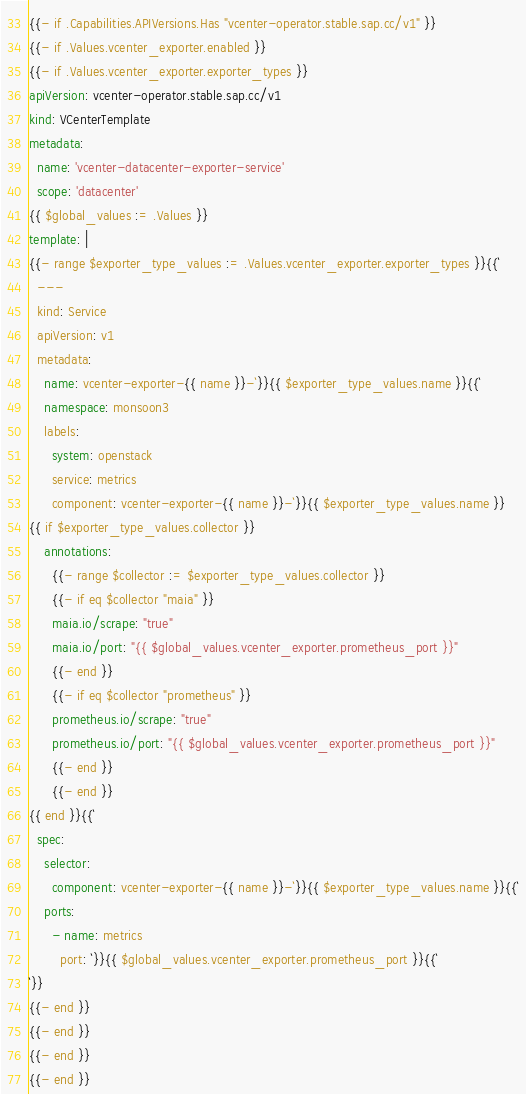Convert code to text. <code><loc_0><loc_0><loc_500><loc_500><_YAML_>{{- if .Capabilities.APIVersions.Has "vcenter-operator.stable.sap.cc/v1" }}
{{- if .Values.vcenter_exporter.enabled }}
{{- if .Values.vcenter_exporter.exporter_types }}
apiVersion: vcenter-operator.stable.sap.cc/v1
kind: VCenterTemplate
metadata:
  name: 'vcenter-datacenter-exporter-service'
  scope: 'datacenter'
{{ $global_values := .Values }}
template: |
{{- range $exporter_type_values := .Values.vcenter_exporter.exporter_types }}{{`
  ---
  kind: Service
  apiVersion: v1
  metadata:
    name: vcenter-exporter-{{ name }}-`}}{{ $exporter_type_values.name }}{{`
    namespace: monsoon3
    labels:
      system: openstack
      service: metrics
      component: vcenter-exporter-{{ name }}-`}}{{ $exporter_type_values.name }}
{{ if $exporter_type_values.collector }}
    annotations:
      {{- range $collector := $exporter_type_values.collector }}
      {{- if eq $collector "maia" }}
      maia.io/scrape: "true"
      maia.io/port: "{{ $global_values.vcenter_exporter.prometheus_port }}"
      {{- end }}
      {{- if eq $collector "prometheus" }}
      prometheus.io/scrape: "true"
      prometheus.io/port: "{{ $global_values.vcenter_exporter.prometheus_port }}"
      {{- end }}
      {{- end }}
{{ end }}{{`
  spec:
    selector:
      component: vcenter-exporter-{{ name }}-`}}{{ $exporter_type_values.name }}{{`
    ports:
      - name: metrics
        port: `}}{{ $global_values.vcenter_exporter.prometheus_port }}{{`
`}}
{{- end }}
{{- end }}
{{- end }}
{{- end }}</code> 